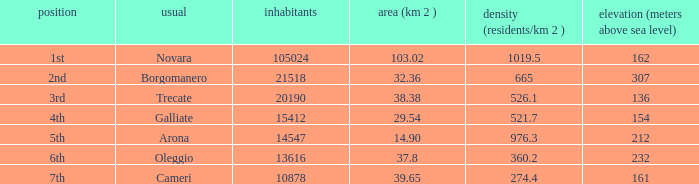Which common possesses an area (km2) of 10 Novara. 